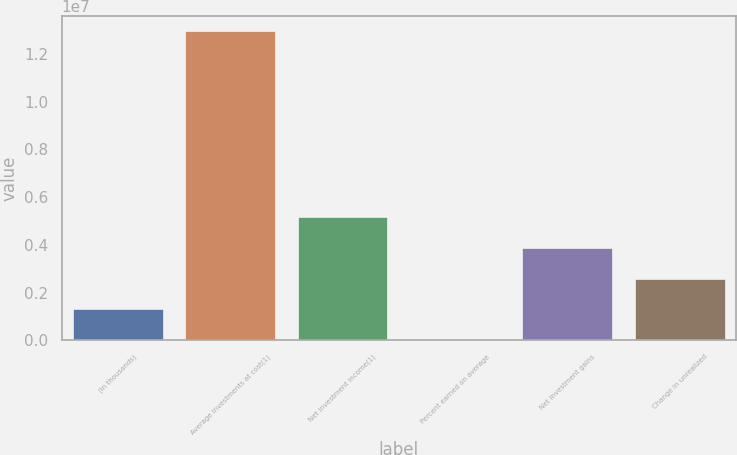Convert chart to OTSL. <chart><loc_0><loc_0><loc_500><loc_500><bar_chart><fcel>(In thousands)<fcel>Average investments at cost(1)<fcel>Net investment income(1)<fcel>Percent earned on average<fcel>Net investment gains<fcel>Change in unrealized<nl><fcel>1.29399e+06<fcel>1.29398e+07<fcel>5.17594e+06<fcel>4.2<fcel>3.88196e+06<fcel>2.58797e+06<nl></chart> 